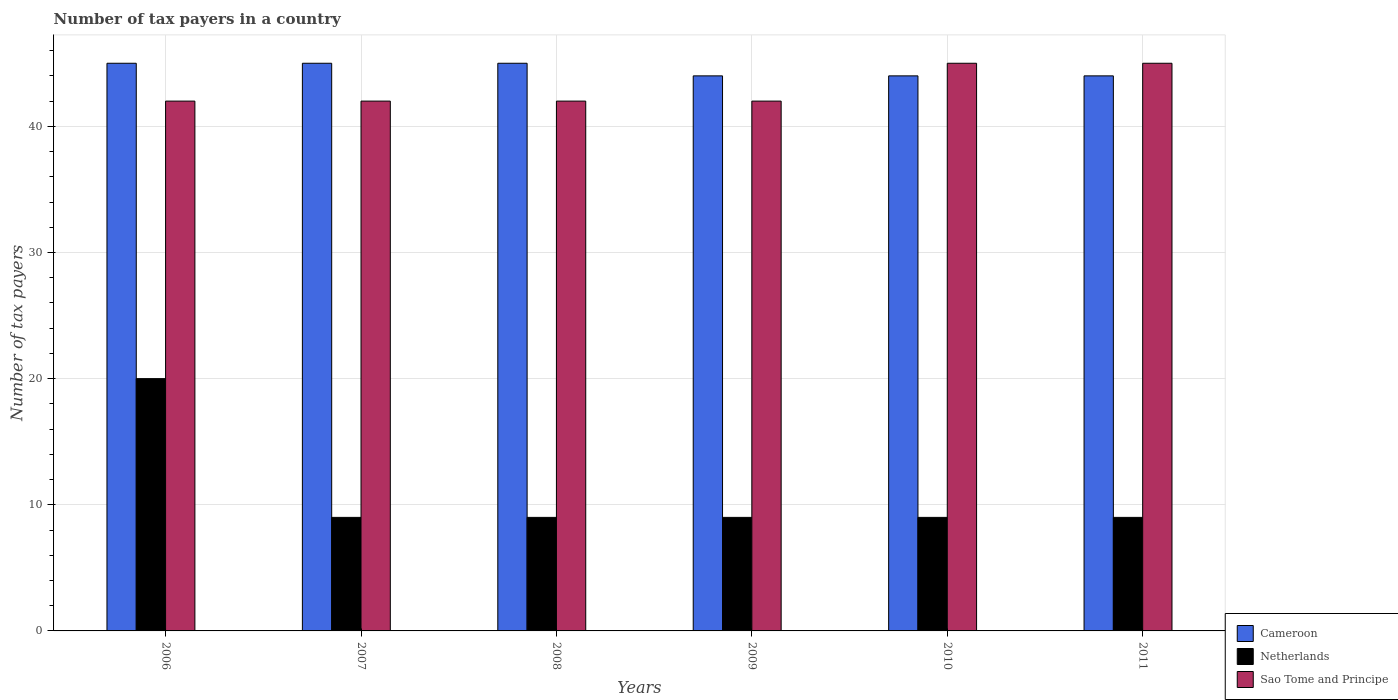Are the number of bars per tick equal to the number of legend labels?
Make the answer very short. Yes. How many bars are there on the 2nd tick from the left?
Your answer should be compact. 3. How many bars are there on the 4th tick from the right?
Offer a very short reply. 3. In how many cases, is the number of bars for a given year not equal to the number of legend labels?
Make the answer very short. 0. What is the number of tax payers in in Cameroon in 2010?
Ensure brevity in your answer.  44. Across all years, what is the maximum number of tax payers in in Netherlands?
Give a very brief answer. 20. Across all years, what is the minimum number of tax payers in in Cameroon?
Offer a very short reply. 44. What is the total number of tax payers in in Cameroon in the graph?
Offer a very short reply. 267. What is the difference between the number of tax payers in in Netherlands in 2006 and that in 2007?
Offer a very short reply. 11. What is the difference between the number of tax payers in in Cameroon in 2007 and the number of tax payers in in Netherlands in 2011?
Keep it short and to the point. 36. What is the average number of tax payers in in Cameroon per year?
Offer a very short reply. 44.5. In the year 2009, what is the difference between the number of tax payers in in Netherlands and number of tax payers in in Sao Tome and Principe?
Keep it short and to the point. -33. What is the ratio of the number of tax payers in in Netherlands in 2008 to that in 2009?
Make the answer very short. 1. Is the difference between the number of tax payers in in Netherlands in 2010 and 2011 greater than the difference between the number of tax payers in in Sao Tome and Principe in 2010 and 2011?
Ensure brevity in your answer.  No. What is the difference between the highest and the second highest number of tax payers in in Cameroon?
Give a very brief answer. 0. What is the difference between the highest and the lowest number of tax payers in in Netherlands?
Your answer should be very brief. 11. In how many years, is the number of tax payers in in Cameroon greater than the average number of tax payers in in Cameroon taken over all years?
Your answer should be compact. 3. What does the 2nd bar from the left in 2007 represents?
Your answer should be very brief. Netherlands. What does the 1st bar from the right in 2010 represents?
Provide a succinct answer. Sao Tome and Principe. Are all the bars in the graph horizontal?
Offer a terse response. No. How many years are there in the graph?
Ensure brevity in your answer.  6. Are the values on the major ticks of Y-axis written in scientific E-notation?
Provide a short and direct response. No. Does the graph contain grids?
Your answer should be very brief. Yes. Where does the legend appear in the graph?
Your answer should be very brief. Bottom right. What is the title of the graph?
Give a very brief answer. Number of tax payers in a country. What is the label or title of the Y-axis?
Your response must be concise. Number of tax payers. What is the Number of tax payers of Cameroon in 2007?
Provide a short and direct response. 45. What is the Number of tax payers of Netherlands in 2007?
Make the answer very short. 9. What is the Number of tax payers of Sao Tome and Principe in 2008?
Give a very brief answer. 42. What is the Number of tax payers of Sao Tome and Principe in 2009?
Your answer should be very brief. 42. What is the Number of tax payers in Cameroon in 2010?
Your response must be concise. 44. What is the Number of tax payers in Netherlands in 2010?
Provide a short and direct response. 9. What is the Number of tax payers in Cameroon in 2011?
Provide a succinct answer. 44. What is the Number of tax payers of Netherlands in 2011?
Provide a short and direct response. 9. Across all years, what is the maximum Number of tax payers of Cameroon?
Give a very brief answer. 45. Across all years, what is the maximum Number of tax payers of Sao Tome and Principe?
Provide a short and direct response. 45. Across all years, what is the minimum Number of tax payers of Sao Tome and Principe?
Offer a very short reply. 42. What is the total Number of tax payers in Cameroon in the graph?
Your response must be concise. 267. What is the total Number of tax payers of Netherlands in the graph?
Provide a succinct answer. 65. What is the total Number of tax payers of Sao Tome and Principe in the graph?
Your answer should be compact. 258. What is the difference between the Number of tax payers in Cameroon in 2006 and that in 2007?
Your answer should be compact. 0. What is the difference between the Number of tax payers of Sao Tome and Principe in 2006 and that in 2007?
Your answer should be very brief. 0. What is the difference between the Number of tax payers in Cameroon in 2006 and that in 2009?
Keep it short and to the point. 1. What is the difference between the Number of tax payers of Netherlands in 2006 and that in 2009?
Provide a short and direct response. 11. What is the difference between the Number of tax payers in Sao Tome and Principe in 2006 and that in 2009?
Offer a very short reply. 0. What is the difference between the Number of tax payers of Netherlands in 2006 and that in 2010?
Provide a short and direct response. 11. What is the difference between the Number of tax payers of Sao Tome and Principe in 2006 and that in 2010?
Provide a short and direct response. -3. What is the difference between the Number of tax payers in Cameroon in 2006 and that in 2011?
Give a very brief answer. 1. What is the difference between the Number of tax payers in Netherlands in 2007 and that in 2008?
Keep it short and to the point. 0. What is the difference between the Number of tax payers of Cameroon in 2007 and that in 2010?
Offer a terse response. 1. What is the difference between the Number of tax payers of Sao Tome and Principe in 2007 and that in 2010?
Offer a terse response. -3. What is the difference between the Number of tax payers in Sao Tome and Principe in 2007 and that in 2011?
Provide a short and direct response. -3. What is the difference between the Number of tax payers in Cameroon in 2008 and that in 2010?
Provide a short and direct response. 1. What is the difference between the Number of tax payers in Sao Tome and Principe in 2008 and that in 2011?
Offer a terse response. -3. What is the difference between the Number of tax payers of Sao Tome and Principe in 2009 and that in 2011?
Provide a short and direct response. -3. What is the difference between the Number of tax payers of Cameroon in 2010 and that in 2011?
Keep it short and to the point. 0. What is the difference between the Number of tax payers in Netherlands in 2010 and that in 2011?
Give a very brief answer. 0. What is the difference between the Number of tax payers in Cameroon in 2006 and the Number of tax payers in Netherlands in 2007?
Your response must be concise. 36. What is the difference between the Number of tax payers of Cameroon in 2006 and the Number of tax payers of Sao Tome and Principe in 2007?
Provide a succinct answer. 3. What is the difference between the Number of tax payers in Netherlands in 2006 and the Number of tax payers in Sao Tome and Principe in 2007?
Your answer should be compact. -22. What is the difference between the Number of tax payers of Cameroon in 2006 and the Number of tax payers of Netherlands in 2009?
Offer a terse response. 36. What is the difference between the Number of tax payers of Cameroon in 2006 and the Number of tax payers of Netherlands in 2010?
Keep it short and to the point. 36. What is the difference between the Number of tax payers of Cameroon in 2006 and the Number of tax payers of Netherlands in 2011?
Give a very brief answer. 36. What is the difference between the Number of tax payers of Cameroon in 2007 and the Number of tax payers of Netherlands in 2008?
Keep it short and to the point. 36. What is the difference between the Number of tax payers of Cameroon in 2007 and the Number of tax payers of Sao Tome and Principe in 2008?
Make the answer very short. 3. What is the difference between the Number of tax payers of Netherlands in 2007 and the Number of tax payers of Sao Tome and Principe in 2008?
Provide a succinct answer. -33. What is the difference between the Number of tax payers of Cameroon in 2007 and the Number of tax payers of Netherlands in 2009?
Provide a short and direct response. 36. What is the difference between the Number of tax payers in Netherlands in 2007 and the Number of tax payers in Sao Tome and Principe in 2009?
Your response must be concise. -33. What is the difference between the Number of tax payers of Cameroon in 2007 and the Number of tax payers of Sao Tome and Principe in 2010?
Ensure brevity in your answer.  0. What is the difference between the Number of tax payers of Netherlands in 2007 and the Number of tax payers of Sao Tome and Principe in 2010?
Your answer should be very brief. -36. What is the difference between the Number of tax payers in Cameroon in 2007 and the Number of tax payers in Netherlands in 2011?
Make the answer very short. 36. What is the difference between the Number of tax payers of Cameroon in 2007 and the Number of tax payers of Sao Tome and Principe in 2011?
Offer a terse response. 0. What is the difference between the Number of tax payers in Netherlands in 2007 and the Number of tax payers in Sao Tome and Principe in 2011?
Your response must be concise. -36. What is the difference between the Number of tax payers in Cameroon in 2008 and the Number of tax payers in Sao Tome and Principe in 2009?
Make the answer very short. 3. What is the difference between the Number of tax payers of Netherlands in 2008 and the Number of tax payers of Sao Tome and Principe in 2009?
Offer a terse response. -33. What is the difference between the Number of tax payers in Cameroon in 2008 and the Number of tax payers in Netherlands in 2010?
Keep it short and to the point. 36. What is the difference between the Number of tax payers in Netherlands in 2008 and the Number of tax payers in Sao Tome and Principe in 2010?
Your response must be concise. -36. What is the difference between the Number of tax payers in Netherlands in 2008 and the Number of tax payers in Sao Tome and Principe in 2011?
Provide a short and direct response. -36. What is the difference between the Number of tax payers of Cameroon in 2009 and the Number of tax payers of Netherlands in 2010?
Offer a very short reply. 35. What is the difference between the Number of tax payers in Netherlands in 2009 and the Number of tax payers in Sao Tome and Principe in 2010?
Ensure brevity in your answer.  -36. What is the difference between the Number of tax payers of Cameroon in 2009 and the Number of tax payers of Sao Tome and Principe in 2011?
Your answer should be very brief. -1. What is the difference between the Number of tax payers of Netherlands in 2009 and the Number of tax payers of Sao Tome and Principe in 2011?
Offer a terse response. -36. What is the difference between the Number of tax payers in Netherlands in 2010 and the Number of tax payers in Sao Tome and Principe in 2011?
Make the answer very short. -36. What is the average Number of tax payers in Cameroon per year?
Offer a very short reply. 44.5. What is the average Number of tax payers of Netherlands per year?
Offer a very short reply. 10.83. In the year 2006, what is the difference between the Number of tax payers in Cameroon and Number of tax payers in Netherlands?
Make the answer very short. 25. In the year 2006, what is the difference between the Number of tax payers of Netherlands and Number of tax payers of Sao Tome and Principe?
Your answer should be very brief. -22. In the year 2007, what is the difference between the Number of tax payers of Netherlands and Number of tax payers of Sao Tome and Principe?
Offer a terse response. -33. In the year 2008, what is the difference between the Number of tax payers of Cameroon and Number of tax payers of Sao Tome and Principe?
Your answer should be very brief. 3. In the year 2008, what is the difference between the Number of tax payers of Netherlands and Number of tax payers of Sao Tome and Principe?
Offer a terse response. -33. In the year 2009, what is the difference between the Number of tax payers of Cameroon and Number of tax payers of Netherlands?
Provide a succinct answer. 35. In the year 2009, what is the difference between the Number of tax payers of Netherlands and Number of tax payers of Sao Tome and Principe?
Your answer should be compact. -33. In the year 2010, what is the difference between the Number of tax payers of Cameroon and Number of tax payers of Netherlands?
Your answer should be very brief. 35. In the year 2010, what is the difference between the Number of tax payers in Cameroon and Number of tax payers in Sao Tome and Principe?
Offer a very short reply. -1. In the year 2010, what is the difference between the Number of tax payers of Netherlands and Number of tax payers of Sao Tome and Principe?
Your response must be concise. -36. In the year 2011, what is the difference between the Number of tax payers in Cameroon and Number of tax payers in Netherlands?
Give a very brief answer. 35. In the year 2011, what is the difference between the Number of tax payers in Cameroon and Number of tax payers in Sao Tome and Principe?
Your response must be concise. -1. In the year 2011, what is the difference between the Number of tax payers of Netherlands and Number of tax payers of Sao Tome and Principe?
Ensure brevity in your answer.  -36. What is the ratio of the Number of tax payers in Cameroon in 2006 to that in 2007?
Provide a succinct answer. 1. What is the ratio of the Number of tax payers in Netherlands in 2006 to that in 2007?
Provide a short and direct response. 2.22. What is the ratio of the Number of tax payers in Sao Tome and Principe in 2006 to that in 2007?
Ensure brevity in your answer.  1. What is the ratio of the Number of tax payers in Netherlands in 2006 to that in 2008?
Keep it short and to the point. 2.22. What is the ratio of the Number of tax payers in Cameroon in 2006 to that in 2009?
Your answer should be very brief. 1.02. What is the ratio of the Number of tax payers in Netherlands in 2006 to that in 2009?
Offer a terse response. 2.22. What is the ratio of the Number of tax payers in Cameroon in 2006 to that in 2010?
Ensure brevity in your answer.  1.02. What is the ratio of the Number of tax payers in Netherlands in 2006 to that in 2010?
Your answer should be very brief. 2.22. What is the ratio of the Number of tax payers in Sao Tome and Principe in 2006 to that in 2010?
Offer a very short reply. 0.93. What is the ratio of the Number of tax payers in Cameroon in 2006 to that in 2011?
Offer a very short reply. 1.02. What is the ratio of the Number of tax payers in Netherlands in 2006 to that in 2011?
Ensure brevity in your answer.  2.22. What is the ratio of the Number of tax payers in Sao Tome and Principe in 2006 to that in 2011?
Your answer should be very brief. 0.93. What is the ratio of the Number of tax payers in Cameroon in 2007 to that in 2008?
Your answer should be compact. 1. What is the ratio of the Number of tax payers in Sao Tome and Principe in 2007 to that in 2008?
Keep it short and to the point. 1. What is the ratio of the Number of tax payers in Cameroon in 2007 to that in 2009?
Your answer should be compact. 1.02. What is the ratio of the Number of tax payers of Sao Tome and Principe in 2007 to that in 2009?
Ensure brevity in your answer.  1. What is the ratio of the Number of tax payers in Cameroon in 2007 to that in 2010?
Provide a succinct answer. 1.02. What is the ratio of the Number of tax payers in Sao Tome and Principe in 2007 to that in 2010?
Your answer should be compact. 0.93. What is the ratio of the Number of tax payers in Cameroon in 2007 to that in 2011?
Your answer should be very brief. 1.02. What is the ratio of the Number of tax payers of Netherlands in 2007 to that in 2011?
Offer a terse response. 1. What is the ratio of the Number of tax payers in Cameroon in 2008 to that in 2009?
Keep it short and to the point. 1.02. What is the ratio of the Number of tax payers in Netherlands in 2008 to that in 2009?
Your answer should be very brief. 1. What is the ratio of the Number of tax payers in Cameroon in 2008 to that in 2010?
Your answer should be compact. 1.02. What is the ratio of the Number of tax payers in Sao Tome and Principe in 2008 to that in 2010?
Offer a terse response. 0.93. What is the ratio of the Number of tax payers of Cameroon in 2008 to that in 2011?
Your answer should be very brief. 1.02. What is the ratio of the Number of tax payers in Netherlands in 2009 to that in 2010?
Make the answer very short. 1. What is the ratio of the Number of tax payers of Cameroon in 2009 to that in 2011?
Offer a very short reply. 1. What is the ratio of the Number of tax payers in Sao Tome and Principe in 2009 to that in 2011?
Keep it short and to the point. 0.93. What is the ratio of the Number of tax payers of Cameroon in 2010 to that in 2011?
Offer a very short reply. 1. What is the difference between the highest and the second highest Number of tax payers of Sao Tome and Principe?
Make the answer very short. 0. What is the difference between the highest and the lowest Number of tax payers of Cameroon?
Make the answer very short. 1. 